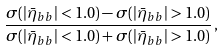Convert formula to latex. <formula><loc_0><loc_0><loc_500><loc_500>\frac { \sigma ( | \bar { \eta } _ { b b } | < 1 . 0 ) - \sigma ( | \bar { \eta } _ { b b } | > 1 . 0 ) } { \sigma ( | \bar { \eta } _ { b b } | < 1 . 0 ) + \sigma ( | \bar { \eta } _ { b b } | > 1 . 0 ) } \, ,</formula> 